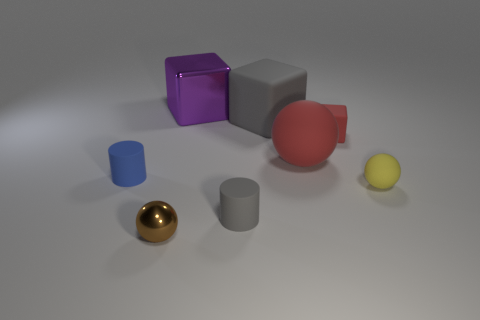Is the material of the red object to the left of the tiny block the same as the cylinder that is in front of the blue object?
Offer a terse response. Yes. There is a large thing in front of the big cube that is on the right side of the big purple metal cube; how many matte balls are to the right of it?
Offer a very short reply. 1. There is a small cylinder that is right of the large purple thing; is its color the same as the tiny matte object that is to the left of the purple cube?
Offer a very short reply. No. Is there any other thing that is the same color as the large sphere?
Offer a very short reply. Yes. What is the color of the tiny cylinder that is behind the ball that is on the right side of the tiny cube?
Offer a very short reply. Blue. Is there a big brown cube?
Your answer should be compact. No. There is a small object that is both in front of the small yellow rubber sphere and right of the small brown metal sphere; what color is it?
Ensure brevity in your answer.  Gray. Does the metal thing behind the large gray block have the same size as the rubber thing that is left of the gray cylinder?
Ensure brevity in your answer.  No. What number of other objects are there of the same size as the yellow matte thing?
Provide a short and direct response. 4. How many large red matte things are behind the cylinder that is to the left of the big metal thing?
Make the answer very short. 1. 